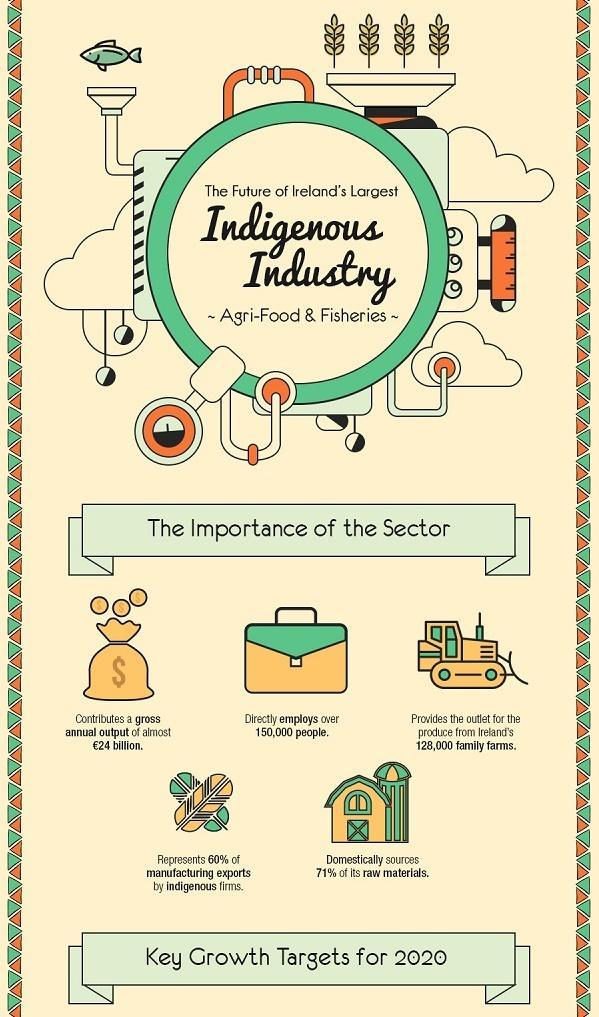what is the colour of the fish, green or yellow
Answer the question with a short phrase. green From where is the major share of the raw materials sourced domestically How many are employed in the indigenous industry 150,000 128,000 family farms depend of which sector Agri-food & Fisheries 